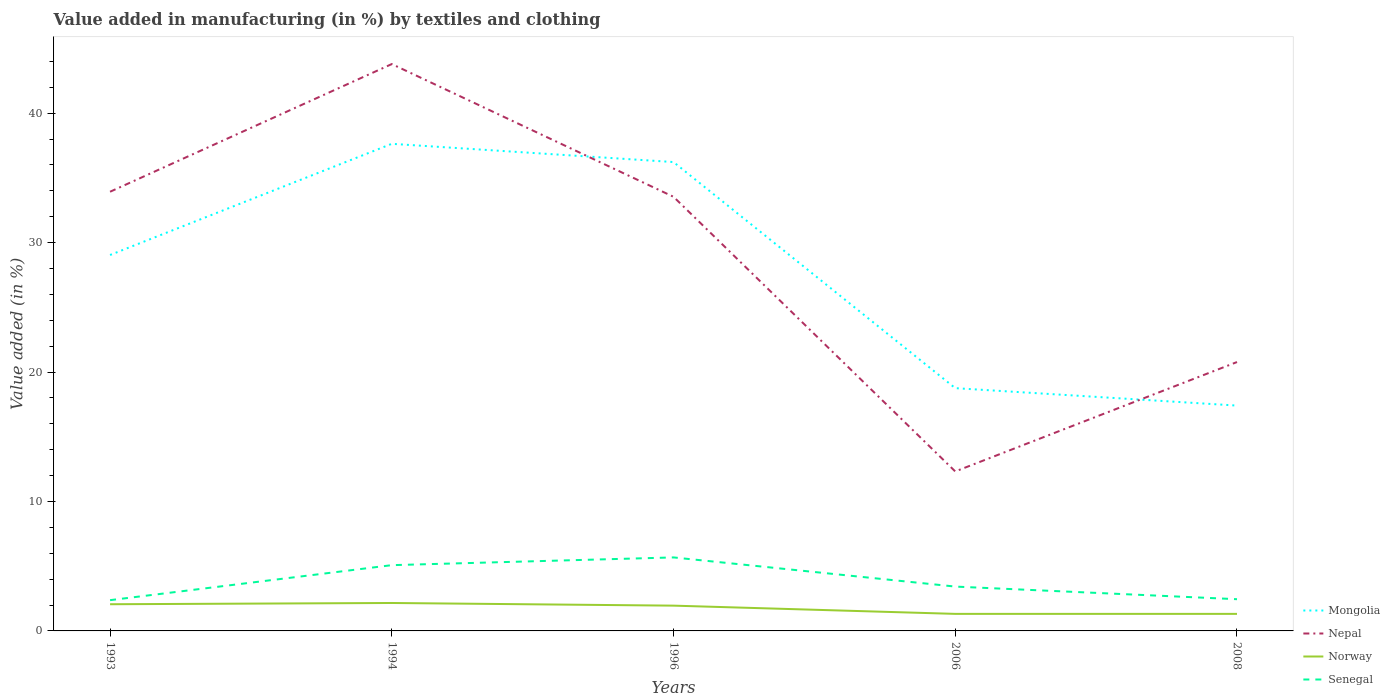Is the number of lines equal to the number of legend labels?
Your response must be concise. Yes. Across all years, what is the maximum percentage of value added in manufacturing by textiles and clothing in Mongolia?
Keep it short and to the point. 17.41. In which year was the percentage of value added in manufacturing by textiles and clothing in Nepal maximum?
Give a very brief answer. 2006. What is the total percentage of value added in manufacturing by textiles and clothing in Norway in the graph?
Offer a very short reply. 0. What is the difference between the highest and the second highest percentage of value added in manufacturing by textiles and clothing in Senegal?
Your answer should be very brief. 3.3. Does the graph contain any zero values?
Provide a short and direct response. No. How are the legend labels stacked?
Provide a succinct answer. Vertical. What is the title of the graph?
Ensure brevity in your answer.  Value added in manufacturing (in %) by textiles and clothing. Does "French Polynesia" appear as one of the legend labels in the graph?
Ensure brevity in your answer.  No. What is the label or title of the Y-axis?
Offer a very short reply. Value added (in %). What is the Value added (in %) in Mongolia in 1993?
Your answer should be compact. 29.04. What is the Value added (in %) in Nepal in 1993?
Provide a short and direct response. 33.93. What is the Value added (in %) of Norway in 1993?
Offer a very short reply. 2.06. What is the Value added (in %) in Senegal in 1993?
Provide a succinct answer. 2.38. What is the Value added (in %) of Mongolia in 1994?
Ensure brevity in your answer.  37.63. What is the Value added (in %) of Nepal in 1994?
Your response must be concise. 43.79. What is the Value added (in %) in Norway in 1994?
Give a very brief answer. 2.16. What is the Value added (in %) in Senegal in 1994?
Make the answer very short. 5.08. What is the Value added (in %) of Mongolia in 1996?
Provide a succinct answer. 36.22. What is the Value added (in %) of Nepal in 1996?
Keep it short and to the point. 33.54. What is the Value added (in %) of Norway in 1996?
Ensure brevity in your answer.  1.95. What is the Value added (in %) of Senegal in 1996?
Make the answer very short. 5.68. What is the Value added (in %) of Mongolia in 2006?
Offer a terse response. 18.76. What is the Value added (in %) of Nepal in 2006?
Provide a short and direct response. 12.32. What is the Value added (in %) of Norway in 2006?
Your response must be concise. 1.32. What is the Value added (in %) in Senegal in 2006?
Offer a very short reply. 3.43. What is the Value added (in %) in Mongolia in 2008?
Your response must be concise. 17.41. What is the Value added (in %) of Nepal in 2008?
Offer a very short reply. 20.77. What is the Value added (in %) in Norway in 2008?
Your answer should be very brief. 1.32. What is the Value added (in %) of Senegal in 2008?
Your response must be concise. 2.45. Across all years, what is the maximum Value added (in %) of Mongolia?
Offer a terse response. 37.63. Across all years, what is the maximum Value added (in %) of Nepal?
Ensure brevity in your answer.  43.79. Across all years, what is the maximum Value added (in %) in Norway?
Offer a very short reply. 2.16. Across all years, what is the maximum Value added (in %) of Senegal?
Keep it short and to the point. 5.68. Across all years, what is the minimum Value added (in %) in Mongolia?
Offer a terse response. 17.41. Across all years, what is the minimum Value added (in %) in Nepal?
Offer a very short reply. 12.32. Across all years, what is the minimum Value added (in %) of Norway?
Your answer should be compact. 1.32. Across all years, what is the minimum Value added (in %) of Senegal?
Make the answer very short. 2.38. What is the total Value added (in %) of Mongolia in the graph?
Provide a short and direct response. 139.06. What is the total Value added (in %) in Nepal in the graph?
Your response must be concise. 144.36. What is the total Value added (in %) in Norway in the graph?
Provide a short and direct response. 8.81. What is the total Value added (in %) of Senegal in the graph?
Your response must be concise. 19.01. What is the difference between the Value added (in %) of Mongolia in 1993 and that in 1994?
Offer a terse response. -8.59. What is the difference between the Value added (in %) of Nepal in 1993 and that in 1994?
Provide a short and direct response. -9.86. What is the difference between the Value added (in %) in Norway in 1993 and that in 1994?
Your answer should be compact. -0.1. What is the difference between the Value added (in %) in Senegal in 1993 and that in 1994?
Your answer should be compact. -2.7. What is the difference between the Value added (in %) in Mongolia in 1993 and that in 1996?
Provide a short and direct response. -7.18. What is the difference between the Value added (in %) of Nepal in 1993 and that in 1996?
Make the answer very short. 0.39. What is the difference between the Value added (in %) of Norway in 1993 and that in 1996?
Your response must be concise. 0.11. What is the difference between the Value added (in %) of Senegal in 1993 and that in 1996?
Your answer should be very brief. -3.3. What is the difference between the Value added (in %) of Mongolia in 1993 and that in 2006?
Offer a very short reply. 10.29. What is the difference between the Value added (in %) in Nepal in 1993 and that in 2006?
Your answer should be very brief. 21.61. What is the difference between the Value added (in %) in Norway in 1993 and that in 2006?
Your answer should be very brief. 0.75. What is the difference between the Value added (in %) of Senegal in 1993 and that in 2006?
Provide a short and direct response. -1.05. What is the difference between the Value added (in %) of Mongolia in 1993 and that in 2008?
Offer a terse response. 11.63. What is the difference between the Value added (in %) in Nepal in 1993 and that in 2008?
Offer a very short reply. 13.16. What is the difference between the Value added (in %) in Norway in 1993 and that in 2008?
Give a very brief answer. 0.75. What is the difference between the Value added (in %) of Senegal in 1993 and that in 2008?
Provide a succinct answer. -0.07. What is the difference between the Value added (in %) in Mongolia in 1994 and that in 1996?
Ensure brevity in your answer.  1.41. What is the difference between the Value added (in %) in Nepal in 1994 and that in 1996?
Give a very brief answer. 10.25. What is the difference between the Value added (in %) of Norway in 1994 and that in 1996?
Ensure brevity in your answer.  0.2. What is the difference between the Value added (in %) of Senegal in 1994 and that in 1996?
Make the answer very short. -0.6. What is the difference between the Value added (in %) in Mongolia in 1994 and that in 2006?
Offer a very short reply. 18.88. What is the difference between the Value added (in %) of Nepal in 1994 and that in 2006?
Provide a succinct answer. 31.47. What is the difference between the Value added (in %) in Norway in 1994 and that in 2006?
Provide a succinct answer. 0.84. What is the difference between the Value added (in %) in Senegal in 1994 and that in 2006?
Your answer should be compact. 1.66. What is the difference between the Value added (in %) of Mongolia in 1994 and that in 2008?
Give a very brief answer. 20.22. What is the difference between the Value added (in %) of Nepal in 1994 and that in 2008?
Your response must be concise. 23.02. What is the difference between the Value added (in %) in Norway in 1994 and that in 2008?
Provide a short and direct response. 0.84. What is the difference between the Value added (in %) of Senegal in 1994 and that in 2008?
Offer a very short reply. 2.63. What is the difference between the Value added (in %) of Mongolia in 1996 and that in 2006?
Give a very brief answer. 17.47. What is the difference between the Value added (in %) of Nepal in 1996 and that in 2006?
Provide a short and direct response. 21.22. What is the difference between the Value added (in %) of Norway in 1996 and that in 2006?
Your response must be concise. 0.64. What is the difference between the Value added (in %) of Senegal in 1996 and that in 2006?
Ensure brevity in your answer.  2.25. What is the difference between the Value added (in %) in Mongolia in 1996 and that in 2008?
Provide a succinct answer. 18.81. What is the difference between the Value added (in %) of Nepal in 1996 and that in 2008?
Make the answer very short. 12.77. What is the difference between the Value added (in %) in Norway in 1996 and that in 2008?
Your answer should be compact. 0.64. What is the difference between the Value added (in %) of Senegal in 1996 and that in 2008?
Provide a succinct answer. 3.23. What is the difference between the Value added (in %) of Mongolia in 2006 and that in 2008?
Offer a terse response. 1.35. What is the difference between the Value added (in %) of Nepal in 2006 and that in 2008?
Offer a terse response. -8.45. What is the difference between the Value added (in %) of Senegal in 2006 and that in 2008?
Your answer should be very brief. 0.98. What is the difference between the Value added (in %) in Mongolia in 1993 and the Value added (in %) in Nepal in 1994?
Make the answer very short. -14.75. What is the difference between the Value added (in %) of Mongolia in 1993 and the Value added (in %) of Norway in 1994?
Provide a succinct answer. 26.89. What is the difference between the Value added (in %) in Mongolia in 1993 and the Value added (in %) in Senegal in 1994?
Give a very brief answer. 23.96. What is the difference between the Value added (in %) of Nepal in 1993 and the Value added (in %) of Norway in 1994?
Provide a short and direct response. 31.77. What is the difference between the Value added (in %) of Nepal in 1993 and the Value added (in %) of Senegal in 1994?
Offer a terse response. 28.85. What is the difference between the Value added (in %) in Norway in 1993 and the Value added (in %) in Senegal in 1994?
Ensure brevity in your answer.  -3.02. What is the difference between the Value added (in %) in Mongolia in 1993 and the Value added (in %) in Nepal in 1996?
Provide a succinct answer. -4.5. What is the difference between the Value added (in %) in Mongolia in 1993 and the Value added (in %) in Norway in 1996?
Keep it short and to the point. 27.09. What is the difference between the Value added (in %) in Mongolia in 1993 and the Value added (in %) in Senegal in 1996?
Give a very brief answer. 23.36. What is the difference between the Value added (in %) of Nepal in 1993 and the Value added (in %) of Norway in 1996?
Your answer should be very brief. 31.98. What is the difference between the Value added (in %) of Nepal in 1993 and the Value added (in %) of Senegal in 1996?
Make the answer very short. 28.25. What is the difference between the Value added (in %) in Norway in 1993 and the Value added (in %) in Senegal in 1996?
Keep it short and to the point. -3.62. What is the difference between the Value added (in %) in Mongolia in 1993 and the Value added (in %) in Nepal in 2006?
Provide a short and direct response. 16.72. What is the difference between the Value added (in %) in Mongolia in 1993 and the Value added (in %) in Norway in 2006?
Offer a very short reply. 27.73. What is the difference between the Value added (in %) of Mongolia in 1993 and the Value added (in %) of Senegal in 2006?
Offer a very short reply. 25.62. What is the difference between the Value added (in %) of Nepal in 1993 and the Value added (in %) of Norway in 2006?
Offer a terse response. 32.61. What is the difference between the Value added (in %) in Nepal in 1993 and the Value added (in %) in Senegal in 2006?
Make the answer very short. 30.5. What is the difference between the Value added (in %) in Norway in 1993 and the Value added (in %) in Senegal in 2006?
Give a very brief answer. -1.36. What is the difference between the Value added (in %) of Mongolia in 1993 and the Value added (in %) of Nepal in 2008?
Keep it short and to the point. 8.27. What is the difference between the Value added (in %) in Mongolia in 1993 and the Value added (in %) in Norway in 2008?
Offer a terse response. 27.73. What is the difference between the Value added (in %) of Mongolia in 1993 and the Value added (in %) of Senegal in 2008?
Make the answer very short. 26.59. What is the difference between the Value added (in %) in Nepal in 1993 and the Value added (in %) in Norway in 2008?
Provide a succinct answer. 32.61. What is the difference between the Value added (in %) of Nepal in 1993 and the Value added (in %) of Senegal in 2008?
Provide a short and direct response. 31.48. What is the difference between the Value added (in %) of Norway in 1993 and the Value added (in %) of Senegal in 2008?
Offer a very short reply. -0.39. What is the difference between the Value added (in %) of Mongolia in 1994 and the Value added (in %) of Nepal in 1996?
Ensure brevity in your answer.  4.09. What is the difference between the Value added (in %) of Mongolia in 1994 and the Value added (in %) of Norway in 1996?
Your answer should be very brief. 35.68. What is the difference between the Value added (in %) of Mongolia in 1994 and the Value added (in %) of Senegal in 1996?
Provide a short and direct response. 31.95. What is the difference between the Value added (in %) in Nepal in 1994 and the Value added (in %) in Norway in 1996?
Your answer should be compact. 41.84. What is the difference between the Value added (in %) of Nepal in 1994 and the Value added (in %) of Senegal in 1996?
Offer a terse response. 38.12. What is the difference between the Value added (in %) of Norway in 1994 and the Value added (in %) of Senegal in 1996?
Provide a succinct answer. -3.52. What is the difference between the Value added (in %) of Mongolia in 1994 and the Value added (in %) of Nepal in 2006?
Ensure brevity in your answer.  25.31. What is the difference between the Value added (in %) of Mongolia in 1994 and the Value added (in %) of Norway in 2006?
Ensure brevity in your answer.  36.32. What is the difference between the Value added (in %) in Mongolia in 1994 and the Value added (in %) in Senegal in 2006?
Offer a very short reply. 34.21. What is the difference between the Value added (in %) of Nepal in 1994 and the Value added (in %) of Norway in 2006?
Make the answer very short. 42.48. What is the difference between the Value added (in %) of Nepal in 1994 and the Value added (in %) of Senegal in 2006?
Ensure brevity in your answer.  40.37. What is the difference between the Value added (in %) in Norway in 1994 and the Value added (in %) in Senegal in 2006?
Make the answer very short. -1.27. What is the difference between the Value added (in %) in Mongolia in 1994 and the Value added (in %) in Nepal in 2008?
Ensure brevity in your answer.  16.86. What is the difference between the Value added (in %) in Mongolia in 1994 and the Value added (in %) in Norway in 2008?
Make the answer very short. 36.32. What is the difference between the Value added (in %) of Mongolia in 1994 and the Value added (in %) of Senegal in 2008?
Your response must be concise. 35.18. What is the difference between the Value added (in %) of Nepal in 1994 and the Value added (in %) of Norway in 2008?
Your response must be concise. 42.48. What is the difference between the Value added (in %) in Nepal in 1994 and the Value added (in %) in Senegal in 2008?
Ensure brevity in your answer.  41.34. What is the difference between the Value added (in %) of Norway in 1994 and the Value added (in %) of Senegal in 2008?
Ensure brevity in your answer.  -0.29. What is the difference between the Value added (in %) in Mongolia in 1996 and the Value added (in %) in Nepal in 2006?
Offer a very short reply. 23.9. What is the difference between the Value added (in %) of Mongolia in 1996 and the Value added (in %) of Norway in 2006?
Provide a succinct answer. 34.91. What is the difference between the Value added (in %) of Mongolia in 1996 and the Value added (in %) of Senegal in 2006?
Your answer should be very brief. 32.8. What is the difference between the Value added (in %) of Nepal in 1996 and the Value added (in %) of Norway in 2006?
Offer a terse response. 32.22. What is the difference between the Value added (in %) of Nepal in 1996 and the Value added (in %) of Senegal in 2006?
Make the answer very short. 30.11. What is the difference between the Value added (in %) in Norway in 1996 and the Value added (in %) in Senegal in 2006?
Your answer should be very brief. -1.47. What is the difference between the Value added (in %) in Mongolia in 1996 and the Value added (in %) in Nepal in 2008?
Give a very brief answer. 15.45. What is the difference between the Value added (in %) of Mongolia in 1996 and the Value added (in %) of Norway in 2008?
Your answer should be very brief. 34.91. What is the difference between the Value added (in %) in Mongolia in 1996 and the Value added (in %) in Senegal in 2008?
Ensure brevity in your answer.  33.77. What is the difference between the Value added (in %) in Nepal in 1996 and the Value added (in %) in Norway in 2008?
Your answer should be very brief. 32.22. What is the difference between the Value added (in %) in Nepal in 1996 and the Value added (in %) in Senegal in 2008?
Keep it short and to the point. 31.09. What is the difference between the Value added (in %) of Norway in 1996 and the Value added (in %) of Senegal in 2008?
Ensure brevity in your answer.  -0.5. What is the difference between the Value added (in %) in Mongolia in 2006 and the Value added (in %) in Nepal in 2008?
Your response must be concise. -2.02. What is the difference between the Value added (in %) of Mongolia in 2006 and the Value added (in %) of Norway in 2008?
Ensure brevity in your answer.  17.44. What is the difference between the Value added (in %) in Mongolia in 2006 and the Value added (in %) in Senegal in 2008?
Your response must be concise. 16.31. What is the difference between the Value added (in %) in Nepal in 2006 and the Value added (in %) in Norway in 2008?
Provide a short and direct response. 11. What is the difference between the Value added (in %) in Nepal in 2006 and the Value added (in %) in Senegal in 2008?
Your answer should be very brief. 9.87. What is the difference between the Value added (in %) in Norway in 2006 and the Value added (in %) in Senegal in 2008?
Your answer should be very brief. -1.13. What is the average Value added (in %) of Mongolia per year?
Your response must be concise. 27.81. What is the average Value added (in %) of Nepal per year?
Give a very brief answer. 28.87. What is the average Value added (in %) in Norway per year?
Provide a short and direct response. 1.76. What is the average Value added (in %) of Senegal per year?
Ensure brevity in your answer.  3.8. In the year 1993, what is the difference between the Value added (in %) of Mongolia and Value added (in %) of Nepal?
Offer a terse response. -4.89. In the year 1993, what is the difference between the Value added (in %) of Mongolia and Value added (in %) of Norway?
Provide a succinct answer. 26.98. In the year 1993, what is the difference between the Value added (in %) of Mongolia and Value added (in %) of Senegal?
Keep it short and to the point. 26.67. In the year 1993, what is the difference between the Value added (in %) of Nepal and Value added (in %) of Norway?
Make the answer very short. 31.87. In the year 1993, what is the difference between the Value added (in %) of Nepal and Value added (in %) of Senegal?
Keep it short and to the point. 31.55. In the year 1993, what is the difference between the Value added (in %) in Norway and Value added (in %) in Senegal?
Ensure brevity in your answer.  -0.31. In the year 1994, what is the difference between the Value added (in %) in Mongolia and Value added (in %) in Nepal?
Your answer should be very brief. -6.16. In the year 1994, what is the difference between the Value added (in %) of Mongolia and Value added (in %) of Norway?
Keep it short and to the point. 35.47. In the year 1994, what is the difference between the Value added (in %) of Mongolia and Value added (in %) of Senegal?
Provide a short and direct response. 32.55. In the year 1994, what is the difference between the Value added (in %) of Nepal and Value added (in %) of Norway?
Give a very brief answer. 41.64. In the year 1994, what is the difference between the Value added (in %) of Nepal and Value added (in %) of Senegal?
Offer a very short reply. 38.71. In the year 1994, what is the difference between the Value added (in %) in Norway and Value added (in %) in Senegal?
Your response must be concise. -2.92. In the year 1996, what is the difference between the Value added (in %) in Mongolia and Value added (in %) in Nepal?
Ensure brevity in your answer.  2.68. In the year 1996, what is the difference between the Value added (in %) of Mongolia and Value added (in %) of Norway?
Your answer should be very brief. 34.27. In the year 1996, what is the difference between the Value added (in %) in Mongolia and Value added (in %) in Senegal?
Provide a succinct answer. 30.54. In the year 1996, what is the difference between the Value added (in %) in Nepal and Value added (in %) in Norway?
Your answer should be compact. 31.59. In the year 1996, what is the difference between the Value added (in %) of Nepal and Value added (in %) of Senegal?
Give a very brief answer. 27.86. In the year 1996, what is the difference between the Value added (in %) of Norway and Value added (in %) of Senegal?
Offer a very short reply. -3.73. In the year 2006, what is the difference between the Value added (in %) in Mongolia and Value added (in %) in Nepal?
Keep it short and to the point. 6.43. In the year 2006, what is the difference between the Value added (in %) in Mongolia and Value added (in %) in Norway?
Offer a terse response. 17.44. In the year 2006, what is the difference between the Value added (in %) in Mongolia and Value added (in %) in Senegal?
Offer a very short reply. 15.33. In the year 2006, what is the difference between the Value added (in %) of Nepal and Value added (in %) of Norway?
Your response must be concise. 11. In the year 2006, what is the difference between the Value added (in %) of Nepal and Value added (in %) of Senegal?
Offer a very short reply. 8.9. In the year 2006, what is the difference between the Value added (in %) of Norway and Value added (in %) of Senegal?
Make the answer very short. -2.11. In the year 2008, what is the difference between the Value added (in %) in Mongolia and Value added (in %) in Nepal?
Provide a succinct answer. -3.36. In the year 2008, what is the difference between the Value added (in %) in Mongolia and Value added (in %) in Norway?
Offer a terse response. 16.09. In the year 2008, what is the difference between the Value added (in %) of Mongolia and Value added (in %) of Senegal?
Your answer should be compact. 14.96. In the year 2008, what is the difference between the Value added (in %) of Nepal and Value added (in %) of Norway?
Your response must be concise. 19.46. In the year 2008, what is the difference between the Value added (in %) in Nepal and Value added (in %) in Senegal?
Ensure brevity in your answer.  18.32. In the year 2008, what is the difference between the Value added (in %) of Norway and Value added (in %) of Senegal?
Your answer should be compact. -1.13. What is the ratio of the Value added (in %) in Mongolia in 1993 to that in 1994?
Give a very brief answer. 0.77. What is the ratio of the Value added (in %) of Nepal in 1993 to that in 1994?
Provide a succinct answer. 0.77. What is the ratio of the Value added (in %) of Norway in 1993 to that in 1994?
Your answer should be very brief. 0.96. What is the ratio of the Value added (in %) in Senegal in 1993 to that in 1994?
Offer a very short reply. 0.47. What is the ratio of the Value added (in %) of Mongolia in 1993 to that in 1996?
Give a very brief answer. 0.8. What is the ratio of the Value added (in %) of Nepal in 1993 to that in 1996?
Give a very brief answer. 1.01. What is the ratio of the Value added (in %) of Norway in 1993 to that in 1996?
Your answer should be very brief. 1.06. What is the ratio of the Value added (in %) in Senegal in 1993 to that in 1996?
Your answer should be very brief. 0.42. What is the ratio of the Value added (in %) of Mongolia in 1993 to that in 2006?
Your response must be concise. 1.55. What is the ratio of the Value added (in %) of Nepal in 1993 to that in 2006?
Provide a short and direct response. 2.75. What is the ratio of the Value added (in %) in Norway in 1993 to that in 2006?
Your answer should be very brief. 1.57. What is the ratio of the Value added (in %) of Senegal in 1993 to that in 2006?
Your answer should be compact. 0.69. What is the ratio of the Value added (in %) of Mongolia in 1993 to that in 2008?
Ensure brevity in your answer.  1.67. What is the ratio of the Value added (in %) in Nepal in 1993 to that in 2008?
Keep it short and to the point. 1.63. What is the ratio of the Value added (in %) in Norway in 1993 to that in 2008?
Your answer should be very brief. 1.57. What is the ratio of the Value added (in %) in Senegal in 1993 to that in 2008?
Your response must be concise. 0.97. What is the ratio of the Value added (in %) in Mongolia in 1994 to that in 1996?
Provide a succinct answer. 1.04. What is the ratio of the Value added (in %) of Nepal in 1994 to that in 1996?
Your answer should be very brief. 1.31. What is the ratio of the Value added (in %) in Norway in 1994 to that in 1996?
Your answer should be compact. 1.1. What is the ratio of the Value added (in %) in Senegal in 1994 to that in 1996?
Provide a succinct answer. 0.89. What is the ratio of the Value added (in %) of Mongolia in 1994 to that in 2006?
Provide a succinct answer. 2.01. What is the ratio of the Value added (in %) of Nepal in 1994 to that in 2006?
Give a very brief answer. 3.55. What is the ratio of the Value added (in %) in Norway in 1994 to that in 2006?
Give a very brief answer. 1.64. What is the ratio of the Value added (in %) of Senegal in 1994 to that in 2006?
Offer a terse response. 1.48. What is the ratio of the Value added (in %) of Mongolia in 1994 to that in 2008?
Your answer should be compact. 2.16. What is the ratio of the Value added (in %) of Nepal in 1994 to that in 2008?
Your answer should be very brief. 2.11. What is the ratio of the Value added (in %) of Norway in 1994 to that in 2008?
Offer a terse response. 1.64. What is the ratio of the Value added (in %) in Senegal in 1994 to that in 2008?
Give a very brief answer. 2.07. What is the ratio of the Value added (in %) in Mongolia in 1996 to that in 2006?
Give a very brief answer. 1.93. What is the ratio of the Value added (in %) of Nepal in 1996 to that in 2006?
Your answer should be compact. 2.72. What is the ratio of the Value added (in %) of Norway in 1996 to that in 2006?
Your answer should be compact. 1.48. What is the ratio of the Value added (in %) of Senegal in 1996 to that in 2006?
Keep it short and to the point. 1.66. What is the ratio of the Value added (in %) of Mongolia in 1996 to that in 2008?
Offer a very short reply. 2.08. What is the ratio of the Value added (in %) in Nepal in 1996 to that in 2008?
Offer a very short reply. 1.61. What is the ratio of the Value added (in %) in Norway in 1996 to that in 2008?
Offer a terse response. 1.48. What is the ratio of the Value added (in %) of Senegal in 1996 to that in 2008?
Your response must be concise. 2.32. What is the ratio of the Value added (in %) of Mongolia in 2006 to that in 2008?
Give a very brief answer. 1.08. What is the ratio of the Value added (in %) in Nepal in 2006 to that in 2008?
Provide a short and direct response. 0.59. What is the ratio of the Value added (in %) in Senegal in 2006 to that in 2008?
Your response must be concise. 1.4. What is the difference between the highest and the second highest Value added (in %) in Mongolia?
Ensure brevity in your answer.  1.41. What is the difference between the highest and the second highest Value added (in %) of Nepal?
Your answer should be very brief. 9.86. What is the difference between the highest and the second highest Value added (in %) in Norway?
Keep it short and to the point. 0.1. What is the difference between the highest and the second highest Value added (in %) of Senegal?
Provide a short and direct response. 0.6. What is the difference between the highest and the lowest Value added (in %) of Mongolia?
Your response must be concise. 20.22. What is the difference between the highest and the lowest Value added (in %) in Nepal?
Give a very brief answer. 31.47. What is the difference between the highest and the lowest Value added (in %) of Norway?
Your response must be concise. 0.84. What is the difference between the highest and the lowest Value added (in %) in Senegal?
Offer a terse response. 3.3. 